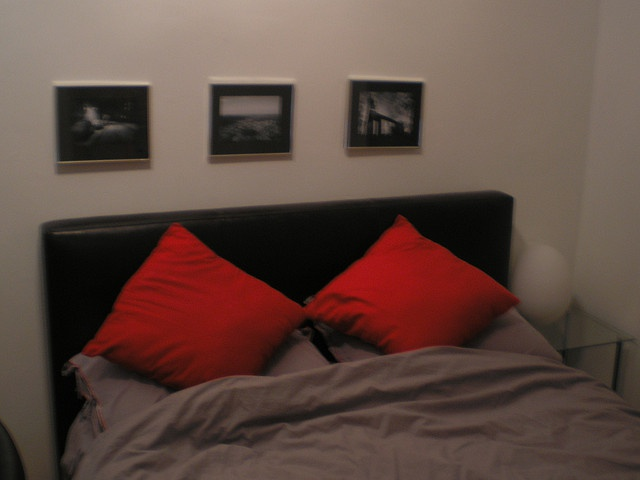Describe the objects in this image and their specific colors. I can see a bed in gray, black, maroon, and brown tones in this image. 